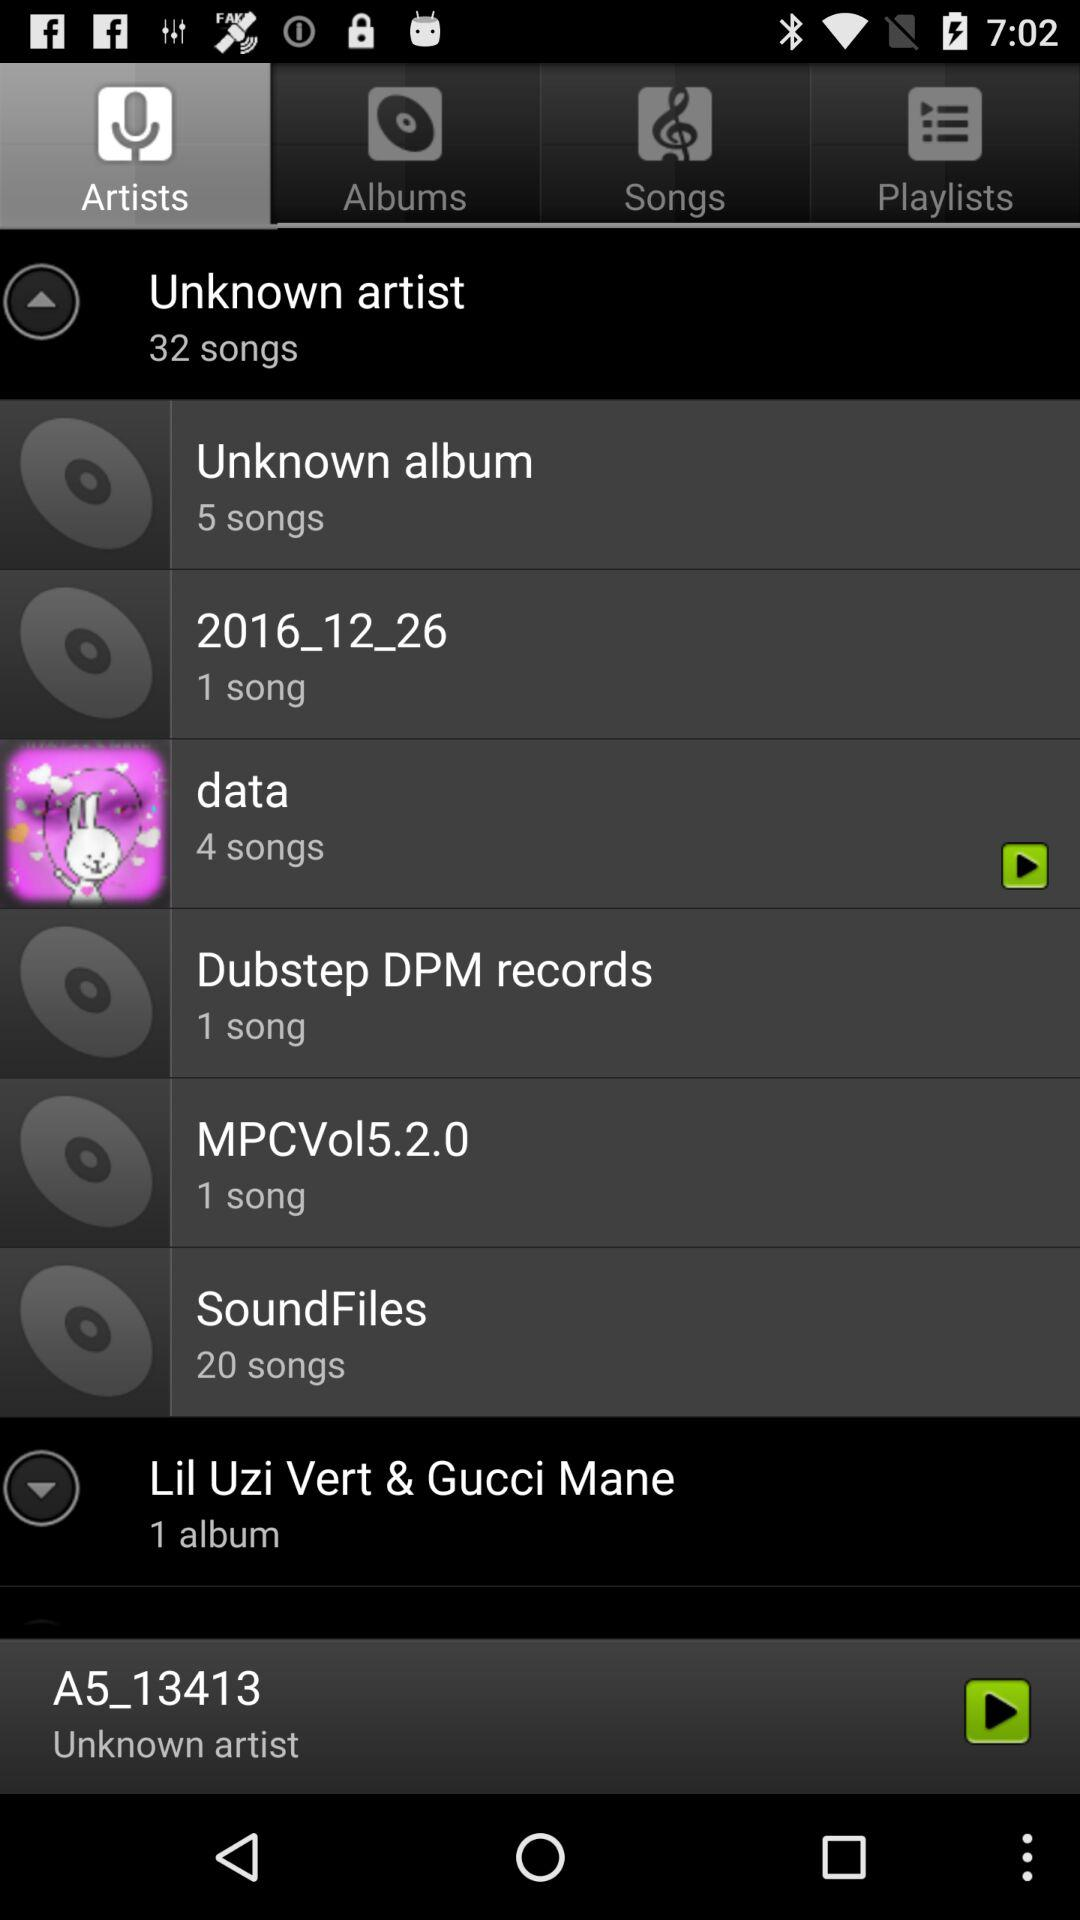How many songs in total are there by unknown artists? There are 32 songs in total. 